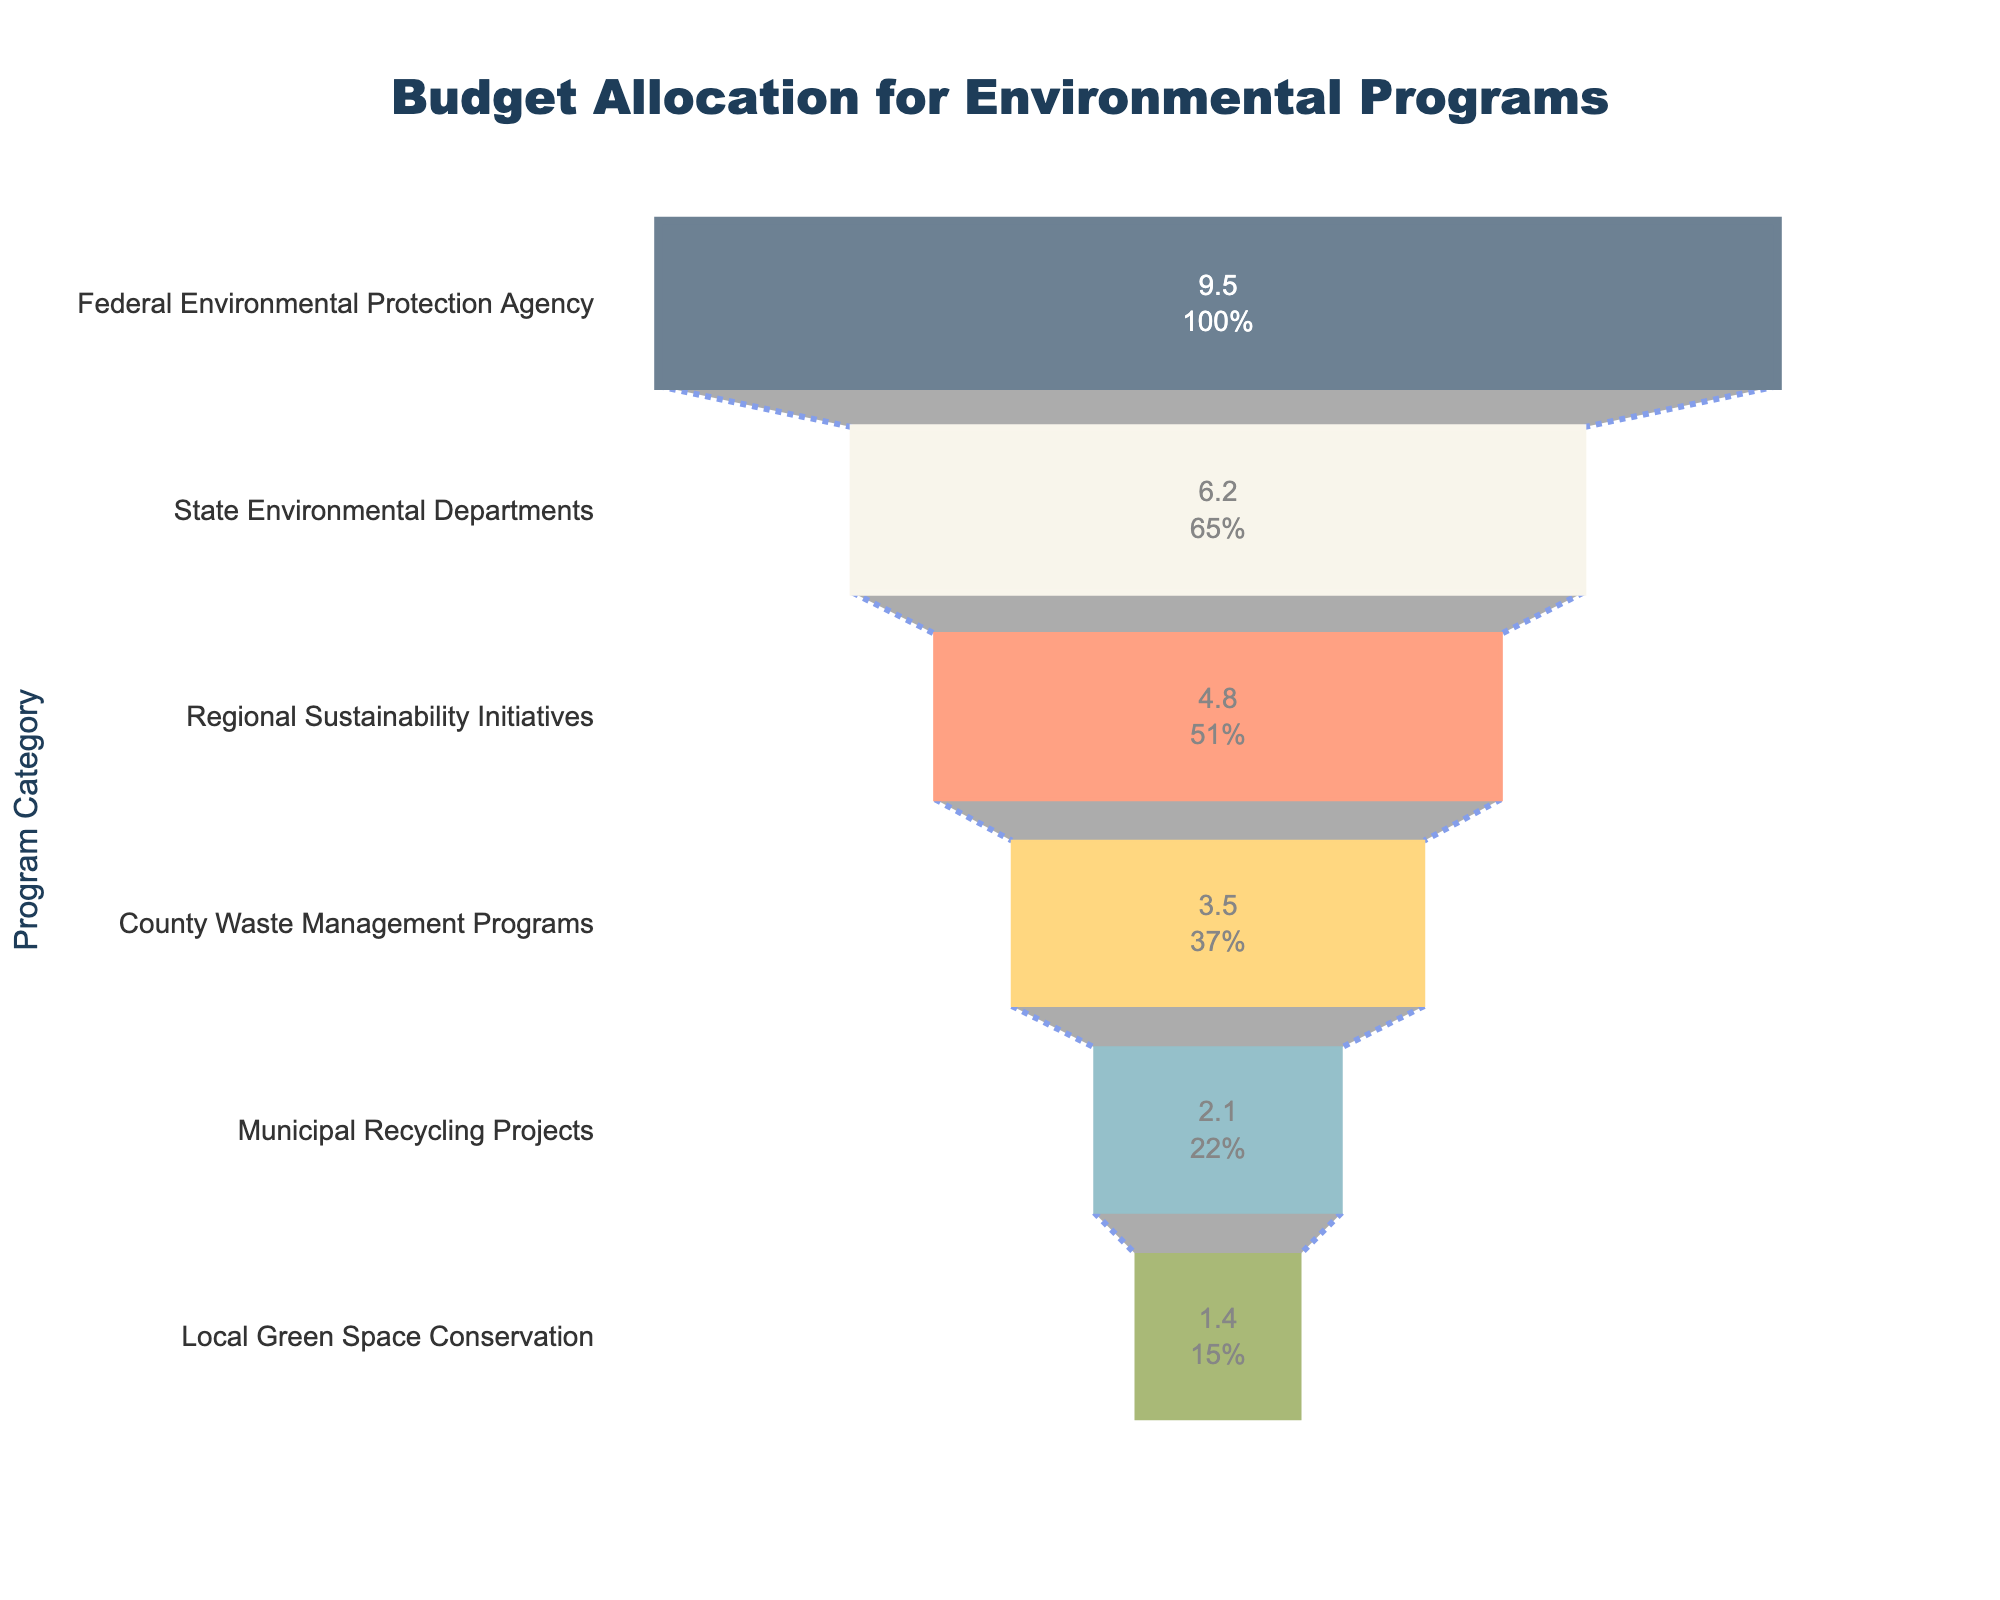What is the title of the chart? The title is usually displayed at the top of the chart. In this case, it is prominent and centered.
Answer: Budget Allocation for Environmental Programs How much budget is allocated to Municipal Recycling Projects? The budget for each category is shown inside the funnel sections. Look for the Municipal Recycling Projects section.
Answer: 2.1 billion USD What category has the largest budget allocation? The largest budget allocation is represented by the widest section at the top of the funnel.
Answer: Federal Environmental Protection Agency How many categories are displayed in the funnel chart? Count the number of distinct sections in the funnel chart.
Answer: 6 What is the combined budget of Regional Sustainability Initiatives and County Waste Management Programs? Add the budgets of Regional Sustainability Initiatives (4.8 billion USD) and County Waste Management Programs (3.5 billion USD).
Answer: 8.3 billion USD By how much does the budget for State Environmental Departments exceed the budget for Local Green Space Conservation? Subtract the budget for Local Green Space Conservation (1.4 billion USD) from the budget for State Environmental Departments (6.2 billion USD).
Answer: 4.8 billion USD Which category has the smallest budget allocation? The smallest budget allocation is represented by the narrowest section at the bottom of the funnel.
Answer: Local Green Space Conservation Compare the budgets for County Waste Management Programs and Municipal Recycling Projects. Which one is higher and by how much? The budget for County Waste Management Programs is 3.5 billion USD, and for Municipal Recycling Projects, it is 2.1 billion USD. Subtract the smaller budget from the larger one.
Answer: County Waste Management Programs by 1.4 billion USD What is the percentage share of the budget allocated to Regional Sustainability Initiatives compared to the total budget? First, sum up all the budget allocations to find the total. Then, divide the budget of Regional Sustainability Initiatives by this total and multiply by 100 to find the percentage.
Answer: 19.2% How does the budget for State Environmental Departments compare to the budget for Regional Sustainability Initiatives? Compare the budget values directly. The State Environmental Departments have a budget of 6.2 billion USD, which is higher than the 4.8 billion USD for Regional Sustainability Initiatives.
Answer: State Environmental Departments have a higher budget 